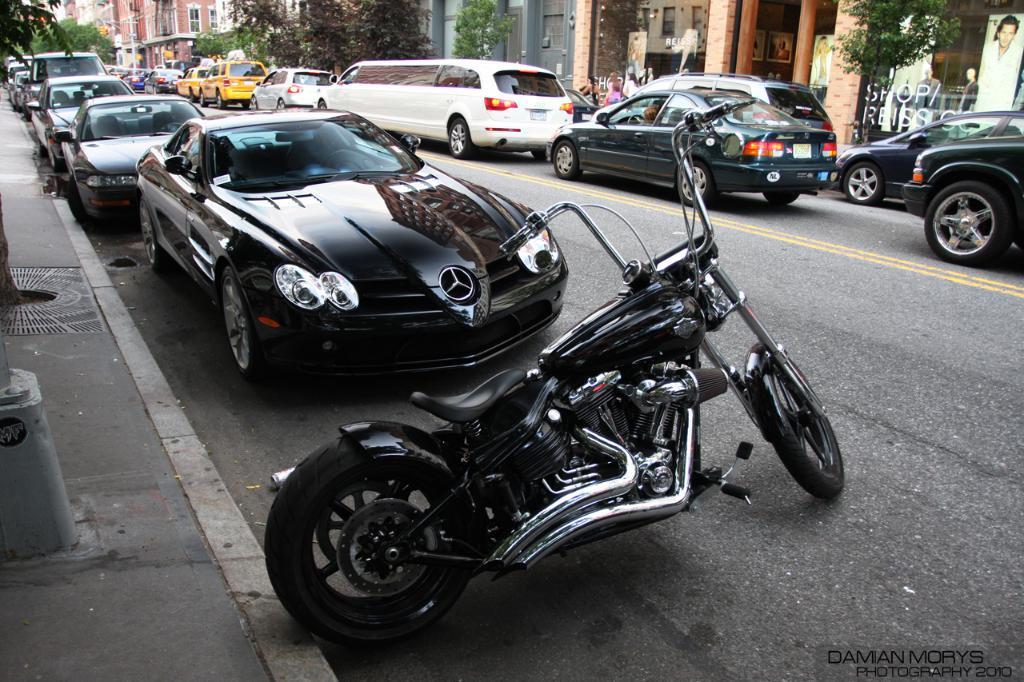Describe this image in one or two sentences. On the left side, there is a pole on a footpath. On the right side, there are vehicles on the road, on which there are two yellow color lines. In the background, there are trees and buildings. 